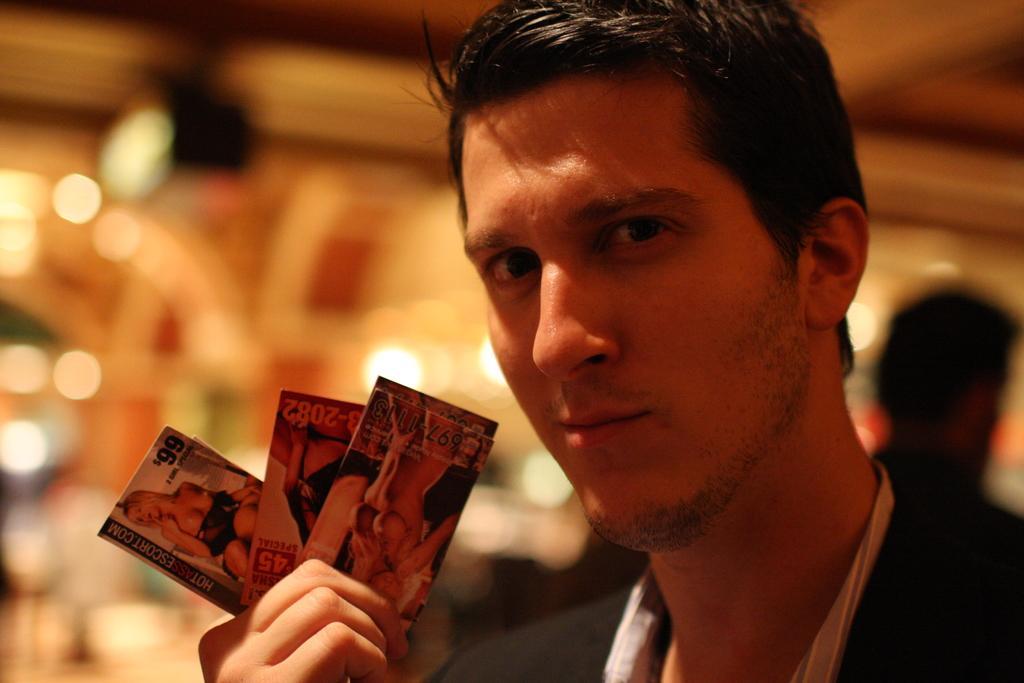Can you describe this image briefly? In this picture we can see a man holding cards with his hand and at the back of him we can see a person, some objects and it is blurry. 